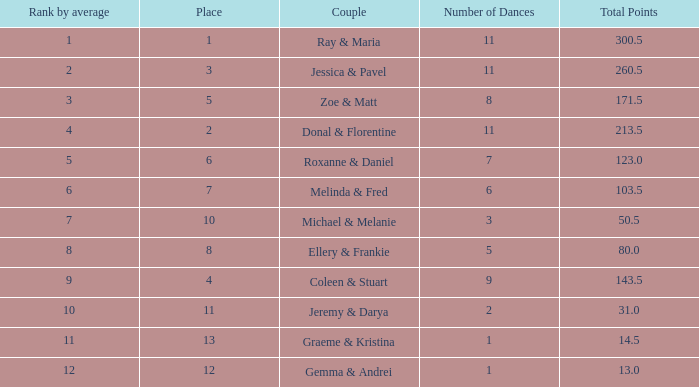Could you parse the entire table? {'header': ['Rank by average', 'Place', 'Couple', 'Number of Dances', 'Total Points'], 'rows': [['1', '1', 'Ray & Maria', '11', '300.5'], ['2', '3', 'Jessica & Pavel', '11', '260.5'], ['3', '5', 'Zoe & Matt', '8', '171.5'], ['4', '2', 'Donal & Florentine', '11', '213.5'], ['5', '6', 'Roxanne & Daniel', '7', '123.0'], ['6', '7', 'Melinda & Fred', '6', '103.5'], ['7', '10', 'Michael & Melanie', '3', '50.5'], ['8', '8', 'Ellery & Frankie', '5', '80.0'], ['9', '4', 'Coleen & Stuart', '9', '143.5'], ['10', '11', 'Jeremy & Darya', '2', '31.0'], ['11', '13', 'Graeme & Kristina', '1', '14.5'], ['12', '12', 'Gemma & Andrei', '1', '13.0']]} What place would you be in if your rank by average is less than 2.0? 1.0. 